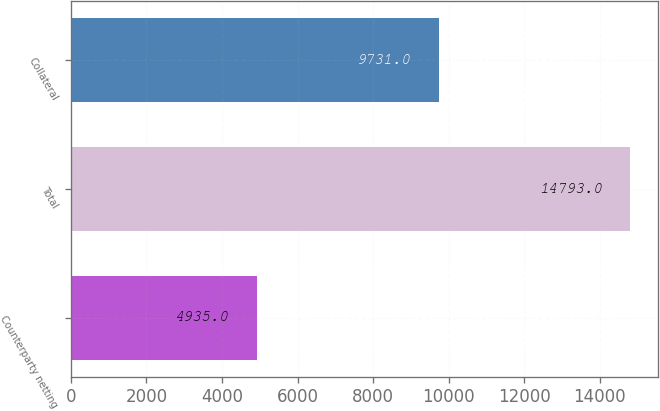<chart> <loc_0><loc_0><loc_500><loc_500><bar_chart><fcel>Counterparty netting<fcel>Total<fcel>Collateral<nl><fcel>4935<fcel>14793<fcel>9731<nl></chart> 